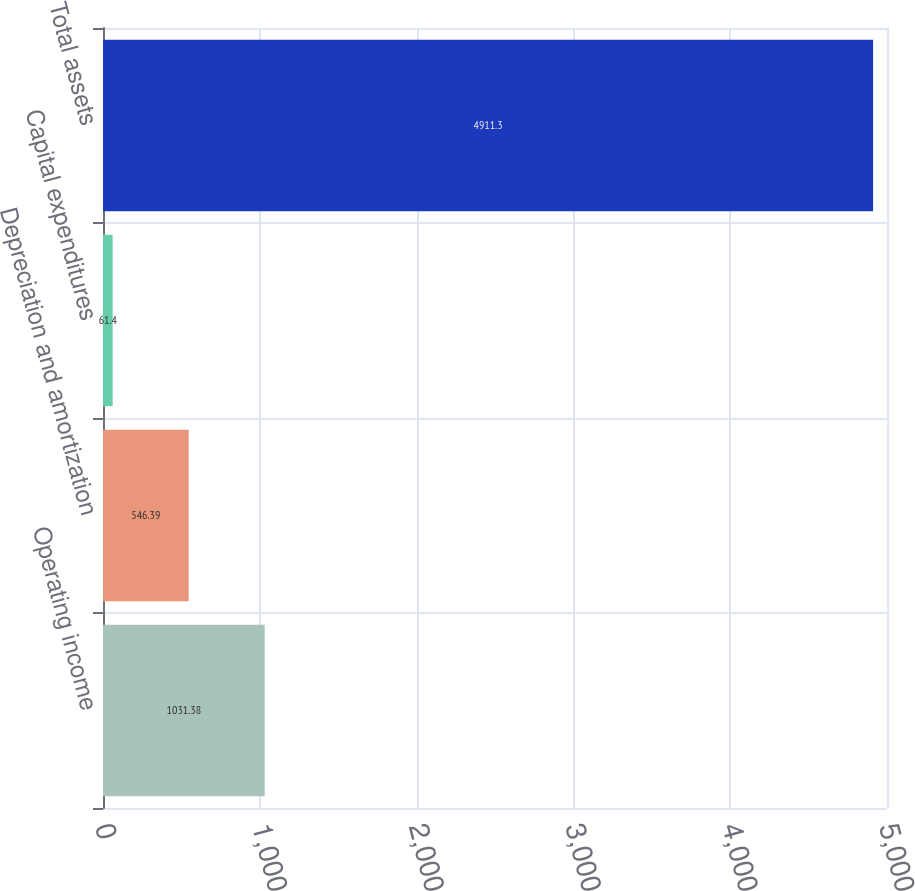<chart> <loc_0><loc_0><loc_500><loc_500><bar_chart><fcel>Operating income<fcel>Depreciation and amortization<fcel>Capital expenditures<fcel>Total assets<nl><fcel>1031.38<fcel>546.39<fcel>61.4<fcel>4911.3<nl></chart> 